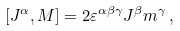Convert formula to latex. <formula><loc_0><loc_0><loc_500><loc_500>[ J ^ { \alpha } , M ] = 2 \varepsilon ^ { \alpha \beta \gamma } J ^ { \beta } m ^ { \gamma } \, ,</formula> 